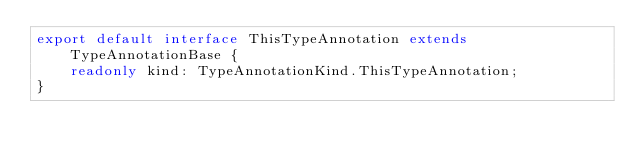Convert code to text. <code><loc_0><loc_0><loc_500><loc_500><_TypeScript_>export default interface ThisTypeAnnotation extends TypeAnnotationBase {
    readonly kind: TypeAnnotationKind.ThisTypeAnnotation;
}
</code> 